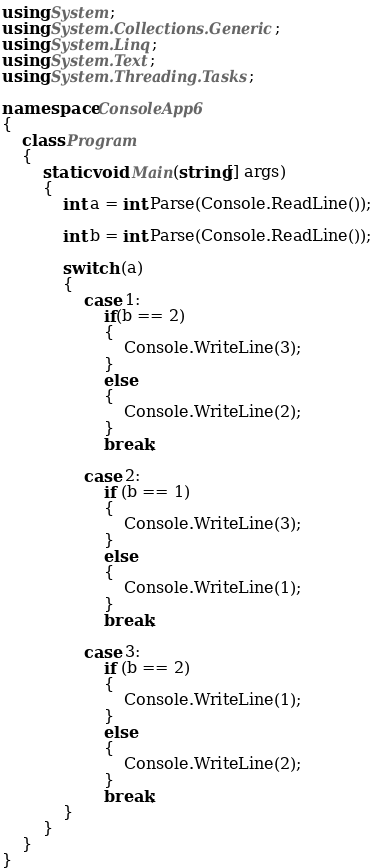<code> <loc_0><loc_0><loc_500><loc_500><_C#_>using System;
using System.Collections.Generic;
using System.Linq;
using System.Text;
using System.Threading.Tasks;

namespace ConsoleApp6
{
    class Program
    {
        static void Main(string[] args)
        {
            int a = int.Parse(Console.ReadLine());

            int b = int.Parse(Console.ReadLine());

            switch (a)
            {
                case 1:
                    if(b == 2)
                    {
                        Console.WriteLine(3);
                    }
                    else
                    {
                        Console.WriteLine(2);
                    }
                    break;

                case 2:
                    if (b == 1)
                    {
                        Console.WriteLine(3);
                    }
                    else
                    {
                        Console.WriteLine(1);
                    }
                    break;

                case 3:
                    if (b == 2)
                    {
                        Console.WriteLine(1);
                    }
                    else
                    {
                        Console.WriteLine(2);
                    }
                    break;
            }
        }
    }
}
</code> 